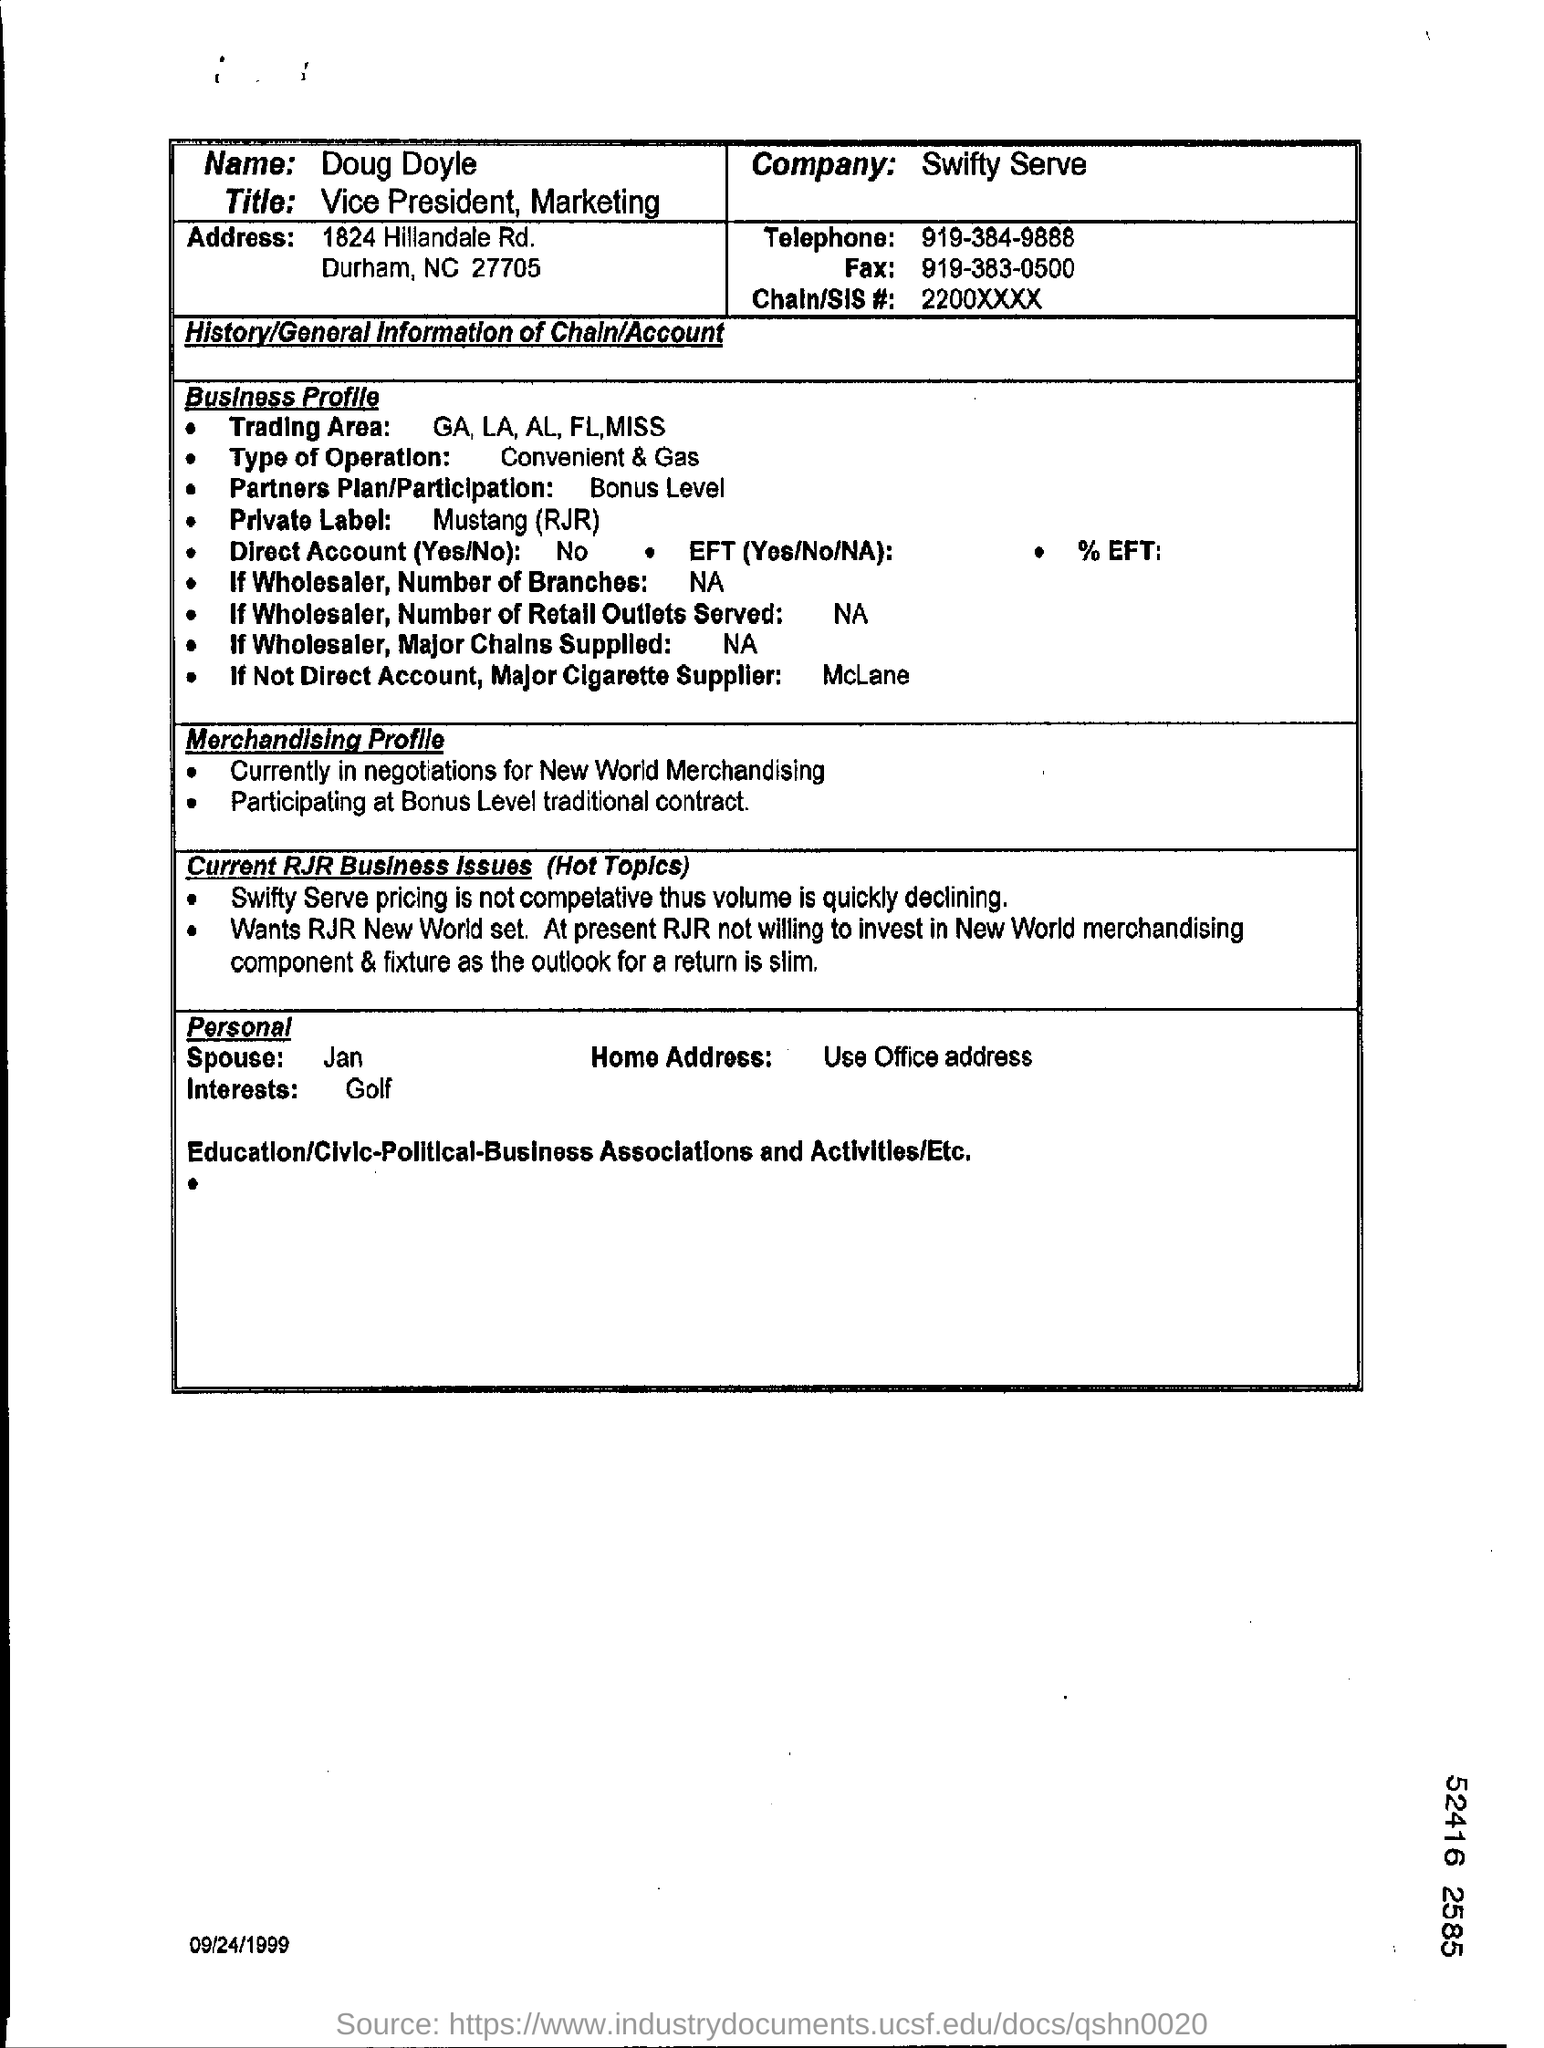Specify some key components in this picture. The telephone number of Doug Doyle is 919-384-9888. The job title of Doug Doyle is Vice President of Marketing. Doug Doyle works in Swifty Serve, a company. The profile belonging to Doug Doyle is given here. The fax number of Doug Doyle is 919-383-0500. 